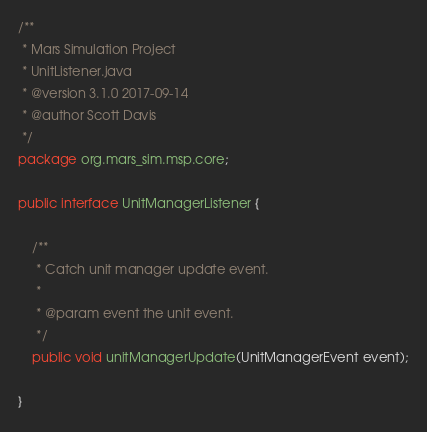<code> <loc_0><loc_0><loc_500><loc_500><_Java_>/**
 * Mars Simulation Project
 * UnitListener.java
 * @version 3.1.0 2017-09-14
 * @author Scott Davis
 */
package org.mars_sim.msp.core;

public interface UnitManagerListener {

	/**
	 * Catch unit manager update event.
	 * 
	 * @param event the unit event.
	 */
	public void unitManagerUpdate(UnitManagerEvent event);

}</code> 